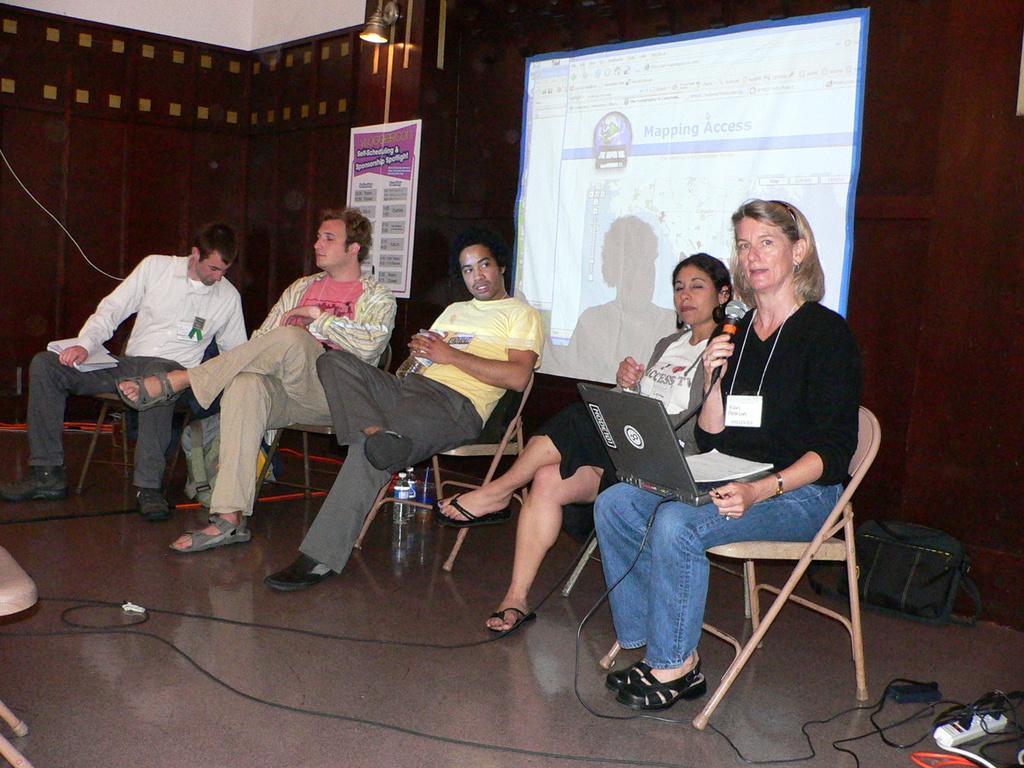Describe this image in one or two sentences. In this image I can see the group of people sitting on the chairs. In the background there is a board,light and the screen. 